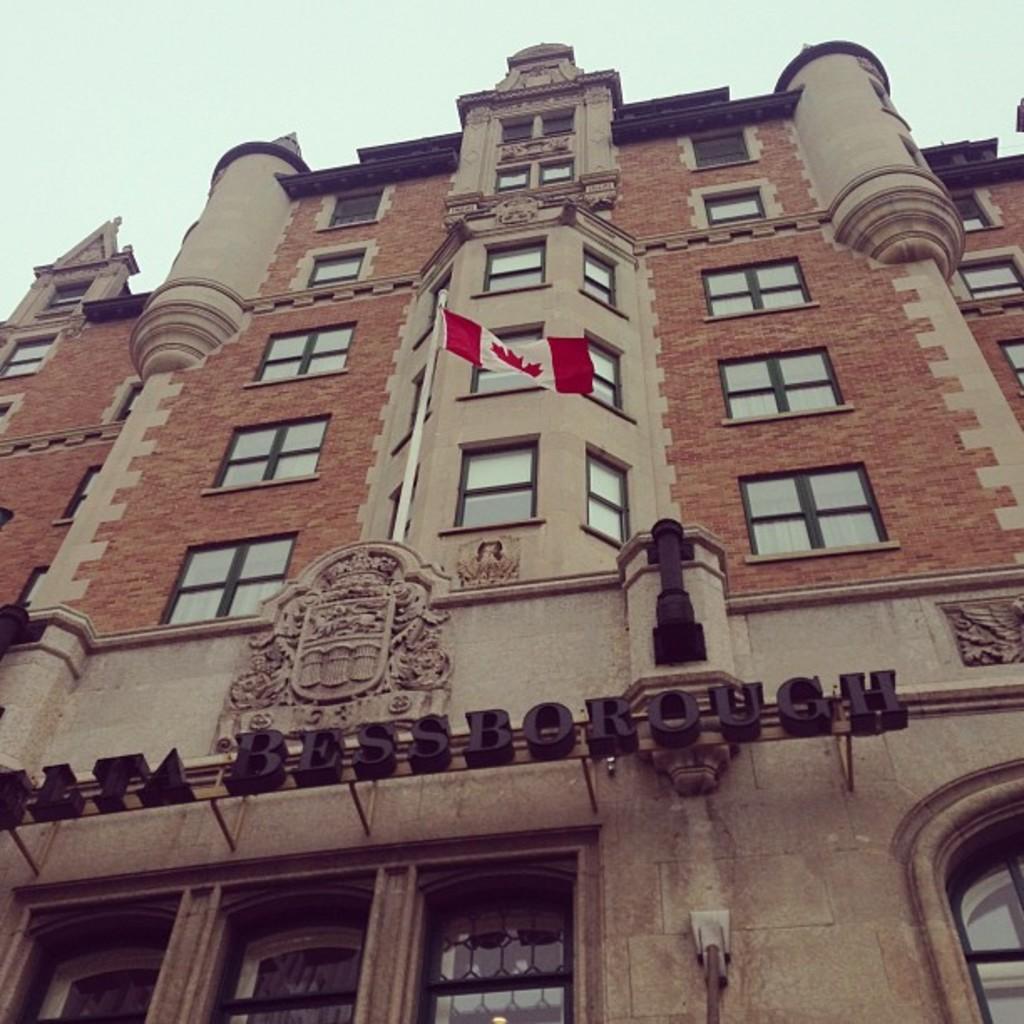In one or two sentences, can you explain what this image depicts? In this image I can see there is a building and there is a flag flying. And there is a rod and there is a design for the building. And there are windows. And at the top there is a sky. 